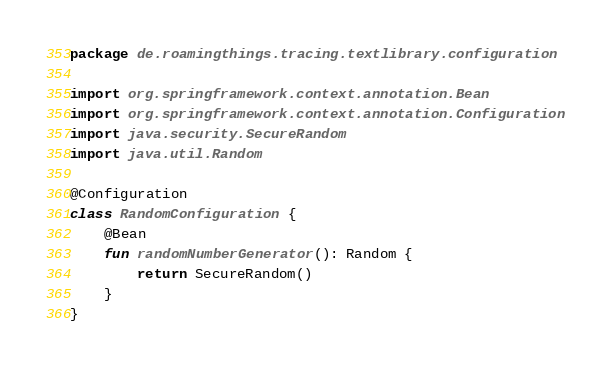<code> <loc_0><loc_0><loc_500><loc_500><_Kotlin_>package de.roamingthings.tracing.textlibrary.configuration

import org.springframework.context.annotation.Bean
import org.springframework.context.annotation.Configuration
import java.security.SecureRandom
import java.util.Random

@Configuration
class RandomConfiguration {
    @Bean
    fun randomNumberGenerator(): Random {
        return SecureRandom()
    }
}
</code> 